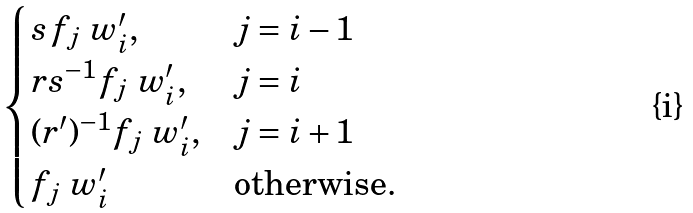<formula> <loc_0><loc_0><loc_500><loc_500>\begin{cases} s \, f _ { j } \ w ^ { \prime } _ { i } , & j = i - 1 \\ r s ^ { - 1 } f _ { j } \ w ^ { \prime } _ { i } , & j = i \\ ( r ^ { \prime } ) ^ { - 1 } f _ { j } \ w ^ { \prime } _ { i } , & j = i + 1 \\ f _ { j } \ w ^ { \prime } _ { i } & \text {otherwise.} \end{cases}</formula> 